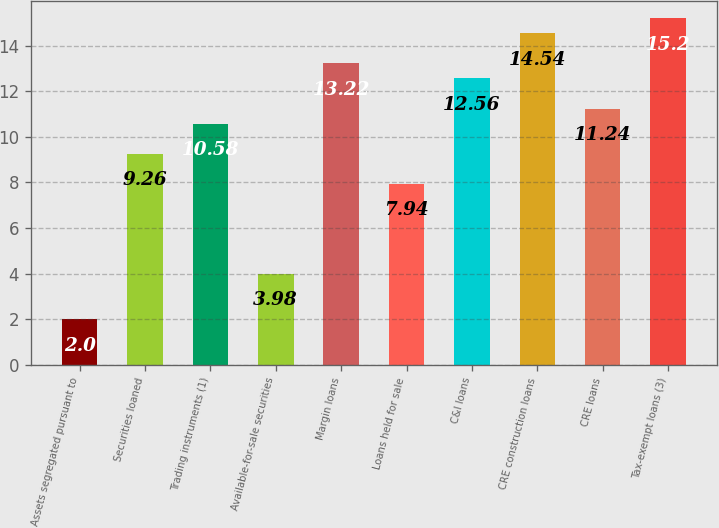Convert chart to OTSL. <chart><loc_0><loc_0><loc_500><loc_500><bar_chart><fcel>Assets segregated pursuant to<fcel>Securities loaned<fcel>Trading instruments (1)<fcel>Available-for-sale securities<fcel>Margin loans<fcel>Loans held for sale<fcel>C&I loans<fcel>CRE construction loans<fcel>CRE loans<fcel>Tax-exempt loans (3)<nl><fcel>2<fcel>9.26<fcel>10.58<fcel>3.98<fcel>13.22<fcel>7.94<fcel>12.56<fcel>14.54<fcel>11.24<fcel>15.2<nl></chart> 